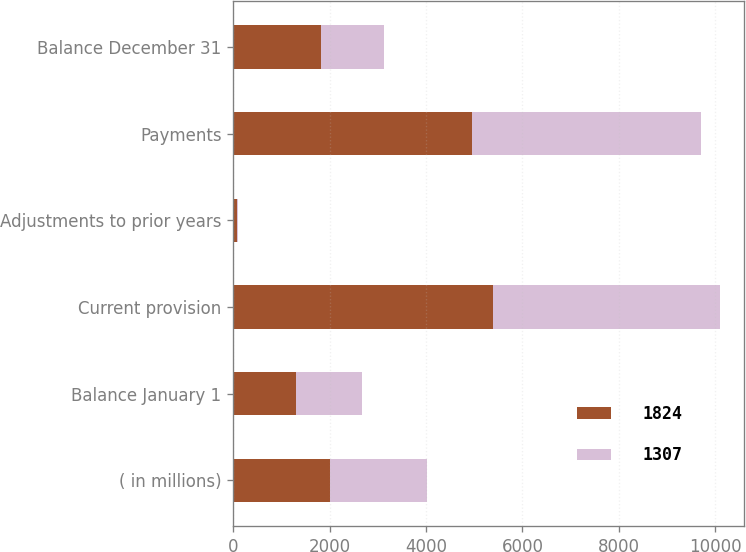Convert chart. <chart><loc_0><loc_0><loc_500><loc_500><stacked_bar_chart><ecel><fcel>( in millions)<fcel>Balance January 1<fcel>Current provision<fcel>Adjustments to prior years<fcel>Payments<fcel>Balance December 31<nl><fcel>1824<fcel>2011<fcel>1307<fcel>5392<fcel>81<fcel>4956<fcel>1824<nl><fcel>1307<fcel>2010<fcel>1373<fcel>4702<fcel>9<fcel>4759<fcel>1307<nl></chart> 